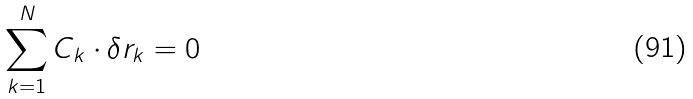<formula> <loc_0><loc_0><loc_500><loc_500>\sum _ { k = 1 } ^ { N } C _ { k } \cdot \delta r _ { k } = 0</formula> 